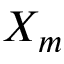<formula> <loc_0><loc_0><loc_500><loc_500>X _ { m }</formula> 